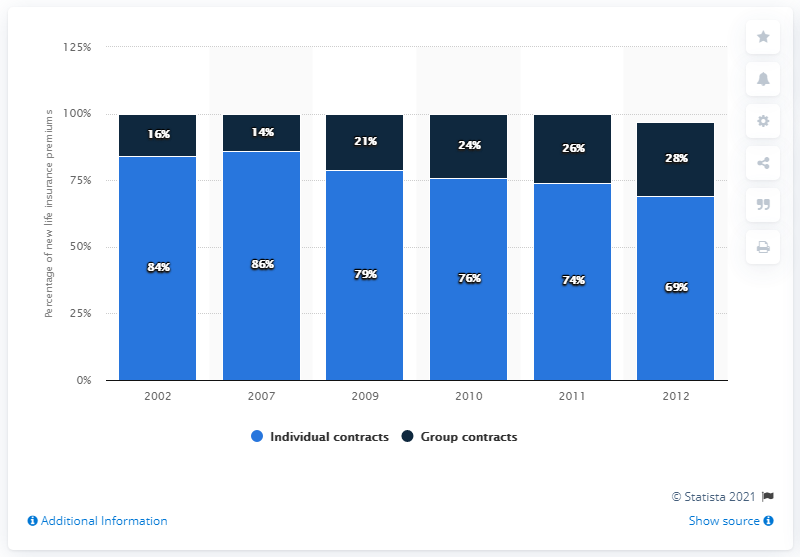Identify some key points in this picture. In 2012, the share of new life insurance premiums in the UK was 69%. In 2011, 74% of the new life insurance premiums in the UK were individual contracts. 